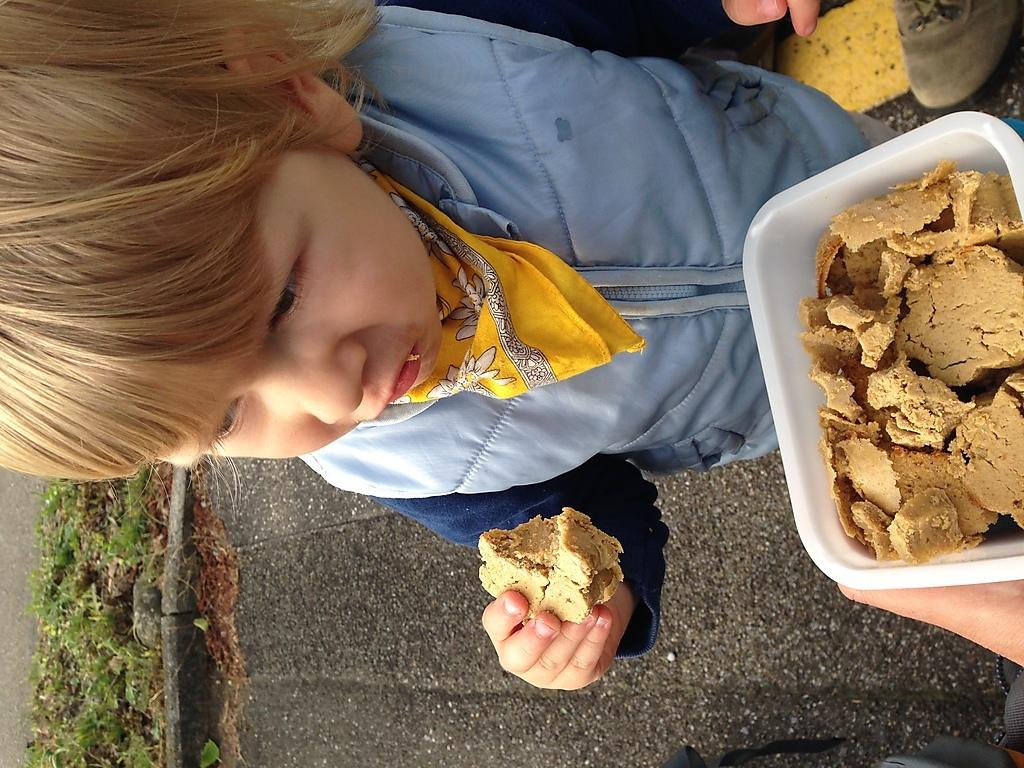Who is the main subject in the image? There is a small girl in the image. Where is the girl located in the image? The girl is at the top side of the image. What is the girl holding in her hand? The girl is holding a biscuit in her hand. What color is the paint on the girl's sister in the image? There is no mention of a sister or paint in the image, so we cannot answer this question. 